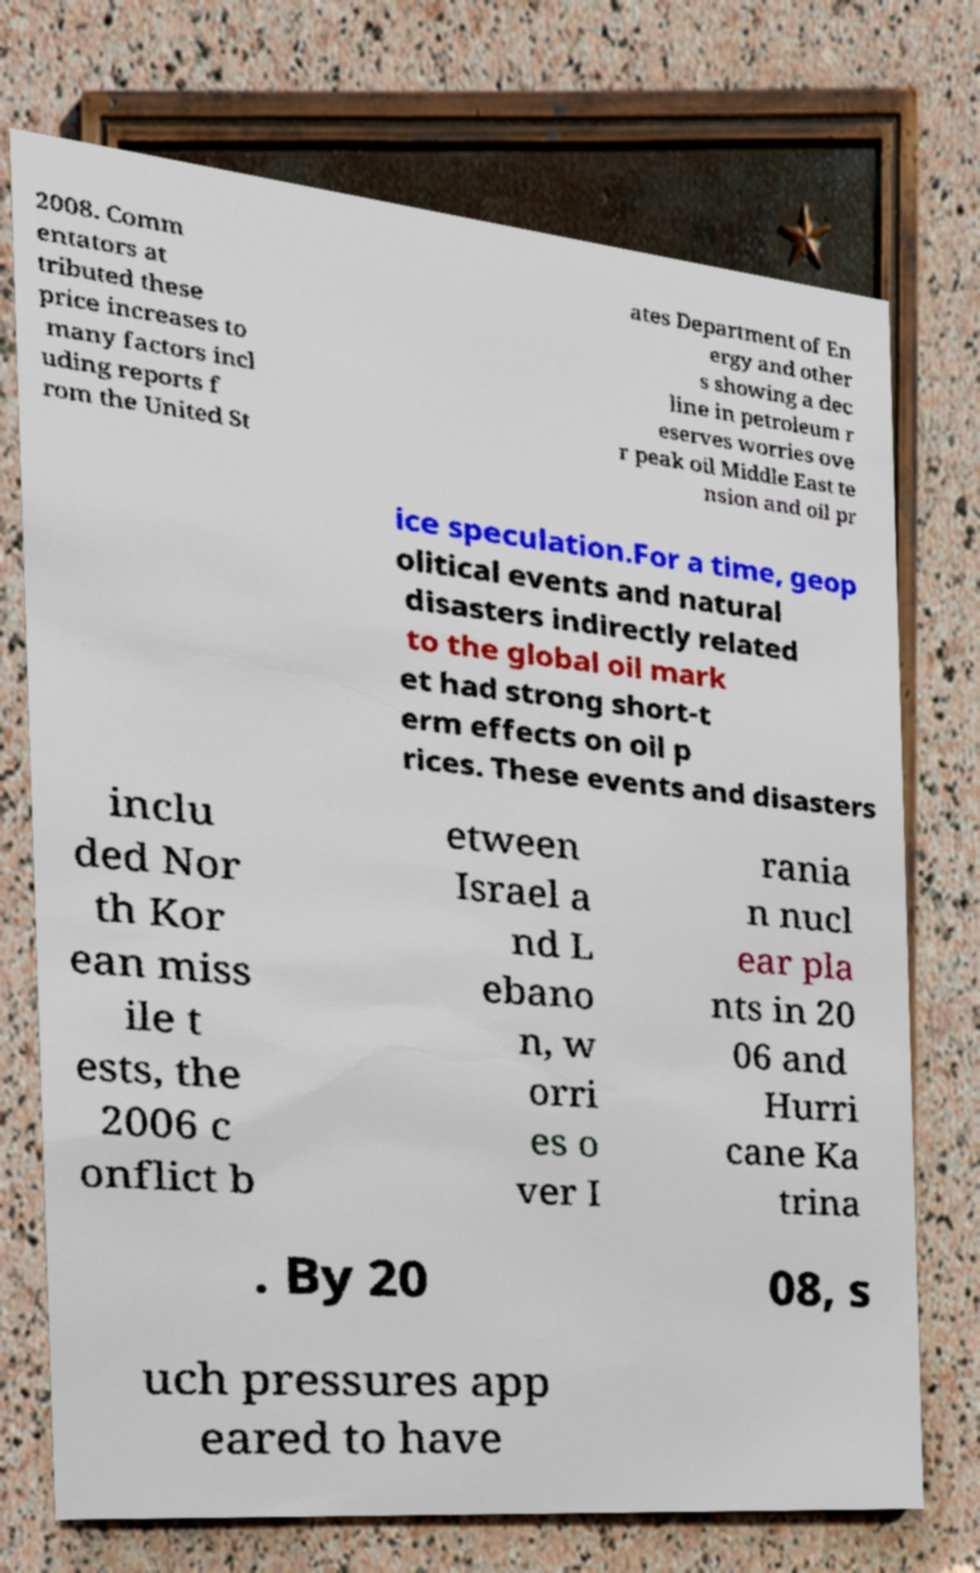There's text embedded in this image that I need extracted. Can you transcribe it verbatim? 2008. Comm entators at tributed these price increases to many factors incl uding reports f rom the United St ates Department of En ergy and other s showing a dec line in petroleum r eserves worries ove r peak oil Middle East te nsion and oil pr ice speculation.For a time, geop olitical events and natural disasters indirectly related to the global oil mark et had strong short-t erm effects on oil p rices. These events and disasters inclu ded Nor th Kor ean miss ile t ests, the 2006 c onflict b etween Israel a nd L ebano n, w orri es o ver I rania n nucl ear pla nts in 20 06 and Hurri cane Ka trina . By 20 08, s uch pressures app eared to have 